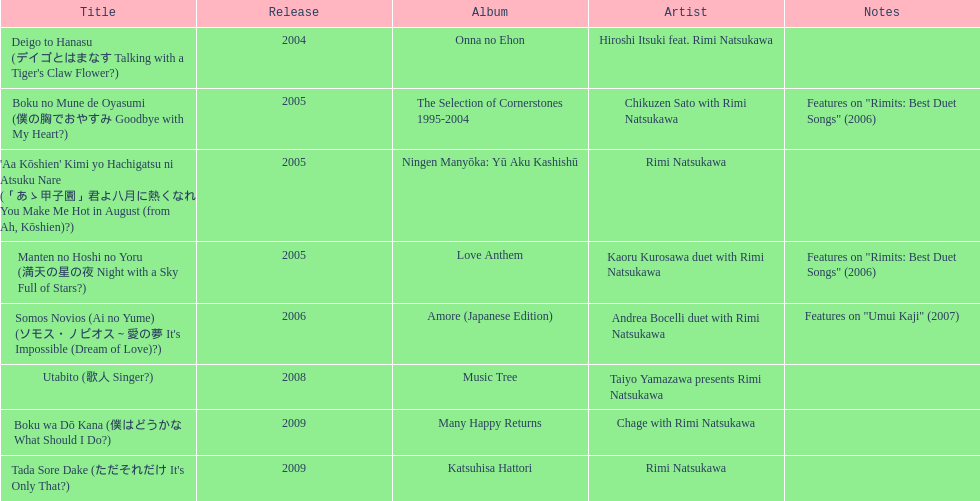What song was this artist on after utabito? Boku wa Dō Kana. 